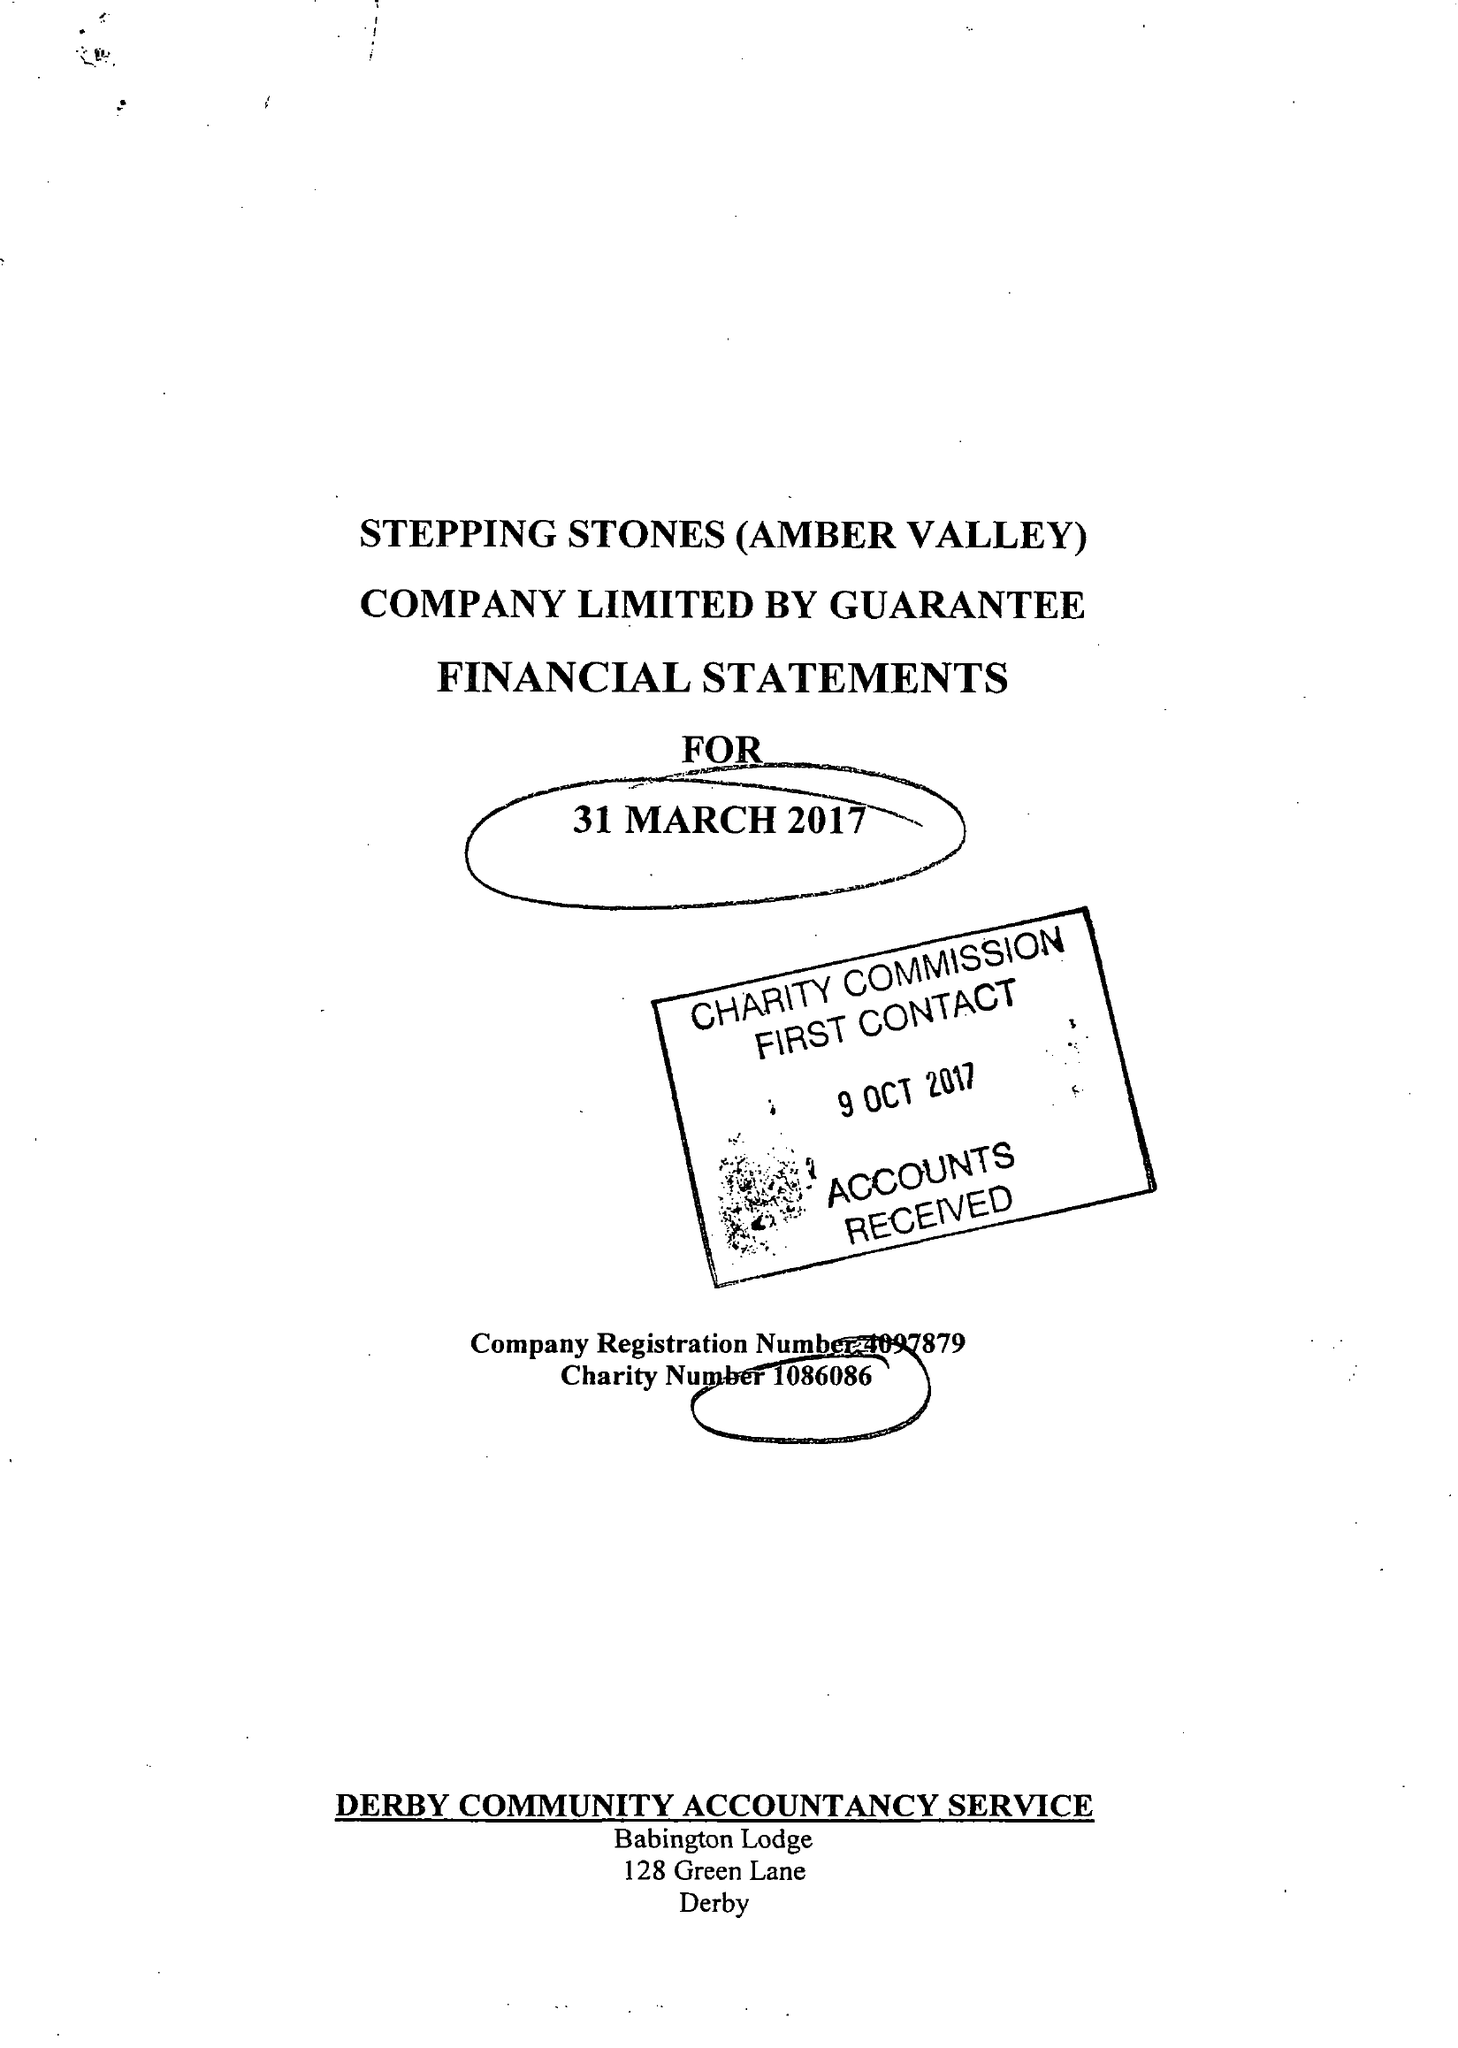What is the value for the charity_number?
Answer the question using a single word or phrase. 1086086 